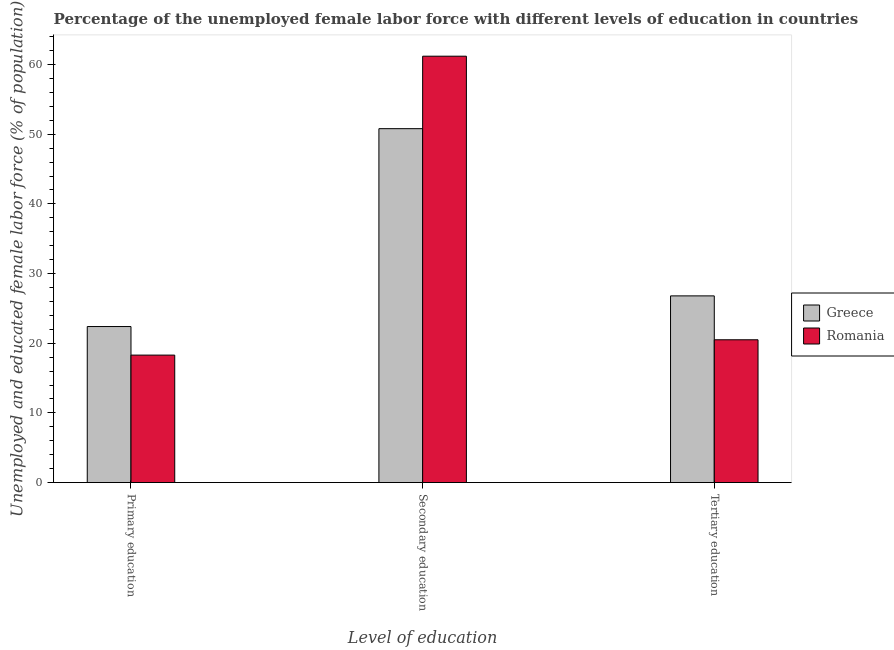How many groups of bars are there?
Your response must be concise. 3. Are the number of bars on each tick of the X-axis equal?
Your answer should be very brief. Yes. How many bars are there on the 1st tick from the left?
Your answer should be compact. 2. What is the label of the 2nd group of bars from the left?
Make the answer very short. Secondary education. Across all countries, what is the maximum percentage of female labor force who received secondary education?
Provide a succinct answer. 61.2. Across all countries, what is the minimum percentage of female labor force who received secondary education?
Offer a terse response. 50.8. In which country was the percentage of female labor force who received tertiary education minimum?
Offer a very short reply. Romania. What is the total percentage of female labor force who received tertiary education in the graph?
Offer a terse response. 47.3. What is the difference between the percentage of female labor force who received tertiary education in Romania and that in Greece?
Give a very brief answer. -6.3. What is the difference between the percentage of female labor force who received secondary education in Greece and the percentage of female labor force who received primary education in Romania?
Provide a succinct answer. 32.5. What is the average percentage of female labor force who received primary education per country?
Give a very brief answer. 20.35. What is the difference between the percentage of female labor force who received primary education and percentage of female labor force who received tertiary education in Greece?
Provide a short and direct response. -4.4. What is the ratio of the percentage of female labor force who received tertiary education in Romania to that in Greece?
Make the answer very short. 0.76. Is the percentage of female labor force who received secondary education in Greece less than that in Romania?
Offer a very short reply. Yes. Is the difference between the percentage of female labor force who received secondary education in Greece and Romania greater than the difference between the percentage of female labor force who received tertiary education in Greece and Romania?
Ensure brevity in your answer.  No. What is the difference between the highest and the second highest percentage of female labor force who received secondary education?
Give a very brief answer. 10.4. What is the difference between the highest and the lowest percentage of female labor force who received tertiary education?
Offer a terse response. 6.3. In how many countries, is the percentage of female labor force who received primary education greater than the average percentage of female labor force who received primary education taken over all countries?
Offer a terse response. 1. What does the 1st bar from the left in Primary education represents?
Offer a terse response. Greece. How many bars are there?
Keep it short and to the point. 6. Are all the bars in the graph horizontal?
Your response must be concise. No. What is the difference between two consecutive major ticks on the Y-axis?
Provide a short and direct response. 10. Are the values on the major ticks of Y-axis written in scientific E-notation?
Your answer should be very brief. No. Does the graph contain any zero values?
Keep it short and to the point. No. Does the graph contain grids?
Ensure brevity in your answer.  No. Where does the legend appear in the graph?
Provide a succinct answer. Center right. What is the title of the graph?
Keep it short and to the point. Percentage of the unemployed female labor force with different levels of education in countries. What is the label or title of the X-axis?
Give a very brief answer. Level of education. What is the label or title of the Y-axis?
Keep it short and to the point. Unemployed and educated female labor force (% of population). What is the Unemployed and educated female labor force (% of population) of Greece in Primary education?
Offer a very short reply. 22.4. What is the Unemployed and educated female labor force (% of population) of Romania in Primary education?
Keep it short and to the point. 18.3. What is the Unemployed and educated female labor force (% of population) of Greece in Secondary education?
Give a very brief answer. 50.8. What is the Unemployed and educated female labor force (% of population) of Romania in Secondary education?
Your answer should be very brief. 61.2. What is the Unemployed and educated female labor force (% of population) of Greece in Tertiary education?
Ensure brevity in your answer.  26.8. What is the Unemployed and educated female labor force (% of population) in Romania in Tertiary education?
Your response must be concise. 20.5. Across all Level of education, what is the maximum Unemployed and educated female labor force (% of population) of Greece?
Your response must be concise. 50.8. Across all Level of education, what is the maximum Unemployed and educated female labor force (% of population) of Romania?
Make the answer very short. 61.2. Across all Level of education, what is the minimum Unemployed and educated female labor force (% of population) in Greece?
Your answer should be compact. 22.4. Across all Level of education, what is the minimum Unemployed and educated female labor force (% of population) of Romania?
Offer a very short reply. 18.3. What is the total Unemployed and educated female labor force (% of population) in Greece in the graph?
Give a very brief answer. 100. What is the total Unemployed and educated female labor force (% of population) of Romania in the graph?
Keep it short and to the point. 100. What is the difference between the Unemployed and educated female labor force (% of population) in Greece in Primary education and that in Secondary education?
Your answer should be compact. -28.4. What is the difference between the Unemployed and educated female labor force (% of population) of Romania in Primary education and that in Secondary education?
Offer a terse response. -42.9. What is the difference between the Unemployed and educated female labor force (% of population) of Greece in Primary education and that in Tertiary education?
Your answer should be very brief. -4.4. What is the difference between the Unemployed and educated female labor force (% of population) in Romania in Primary education and that in Tertiary education?
Offer a very short reply. -2.2. What is the difference between the Unemployed and educated female labor force (% of population) of Greece in Secondary education and that in Tertiary education?
Give a very brief answer. 24. What is the difference between the Unemployed and educated female labor force (% of population) of Romania in Secondary education and that in Tertiary education?
Give a very brief answer. 40.7. What is the difference between the Unemployed and educated female labor force (% of population) in Greece in Primary education and the Unemployed and educated female labor force (% of population) in Romania in Secondary education?
Provide a succinct answer. -38.8. What is the difference between the Unemployed and educated female labor force (% of population) of Greece in Secondary education and the Unemployed and educated female labor force (% of population) of Romania in Tertiary education?
Your answer should be compact. 30.3. What is the average Unemployed and educated female labor force (% of population) of Greece per Level of education?
Your answer should be compact. 33.33. What is the average Unemployed and educated female labor force (% of population) of Romania per Level of education?
Offer a very short reply. 33.33. What is the difference between the Unemployed and educated female labor force (% of population) in Greece and Unemployed and educated female labor force (% of population) in Romania in Secondary education?
Your answer should be compact. -10.4. What is the difference between the Unemployed and educated female labor force (% of population) of Greece and Unemployed and educated female labor force (% of population) of Romania in Tertiary education?
Offer a terse response. 6.3. What is the ratio of the Unemployed and educated female labor force (% of population) in Greece in Primary education to that in Secondary education?
Your answer should be very brief. 0.44. What is the ratio of the Unemployed and educated female labor force (% of population) in Romania in Primary education to that in Secondary education?
Your response must be concise. 0.3. What is the ratio of the Unemployed and educated female labor force (% of population) of Greece in Primary education to that in Tertiary education?
Your answer should be compact. 0.84. What is the ratio of the Unemployed and educated female labor force (% of population) in Romania in Primary education to that in Tertiary education?
Your response must be concise. 0.89. What is the ratio of the Unemployed and educated female labor force (% of population) in Greece in Secondary education to that in Tertiary education?
Provide a short and direct response. 1.9. What is the ratio of the Unemployed and educated female labor force (% of population) in Romania in Secondary education to that in Tertiary education?
Your answer should be very brief. 2.99. What is the difference between the highest and the second highest Unemployed and educated female labor force (% of population) of Romania?
Make the answer very short. 40.7. What is the difference between the highest and the lowest Unemployed and educated female labor force (% of population) of Greece?
Provide a succinct answer. 28.4. What is the difference between the highest and the lowest Unemployed and educated female labor force (% of population) in Romania?
Ensure brevity in your answer.  42.9. 